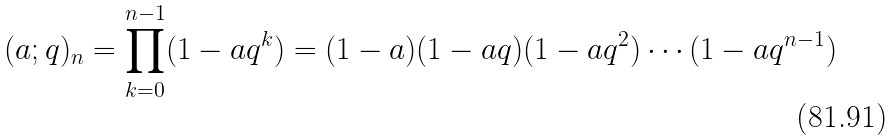Convert formula to latex. <formula><loc_0><loc_0><loc_500><loc_500>( a ; q ) _ { n } = \prod _ { k = 0 } ^ { n - 1 } ( 1 - a q ^ { k } ) = ( 1 - a ) ( 1 - a q ) ( 1 - a q ^ { 2 } ) \cdots ( 1 - a q ^ { n - 1 } )</formula> 